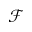Convert formula to latex. <formula><loc_0><loc_0><loc_500><loc_500>\mathcal { F }</formula> 